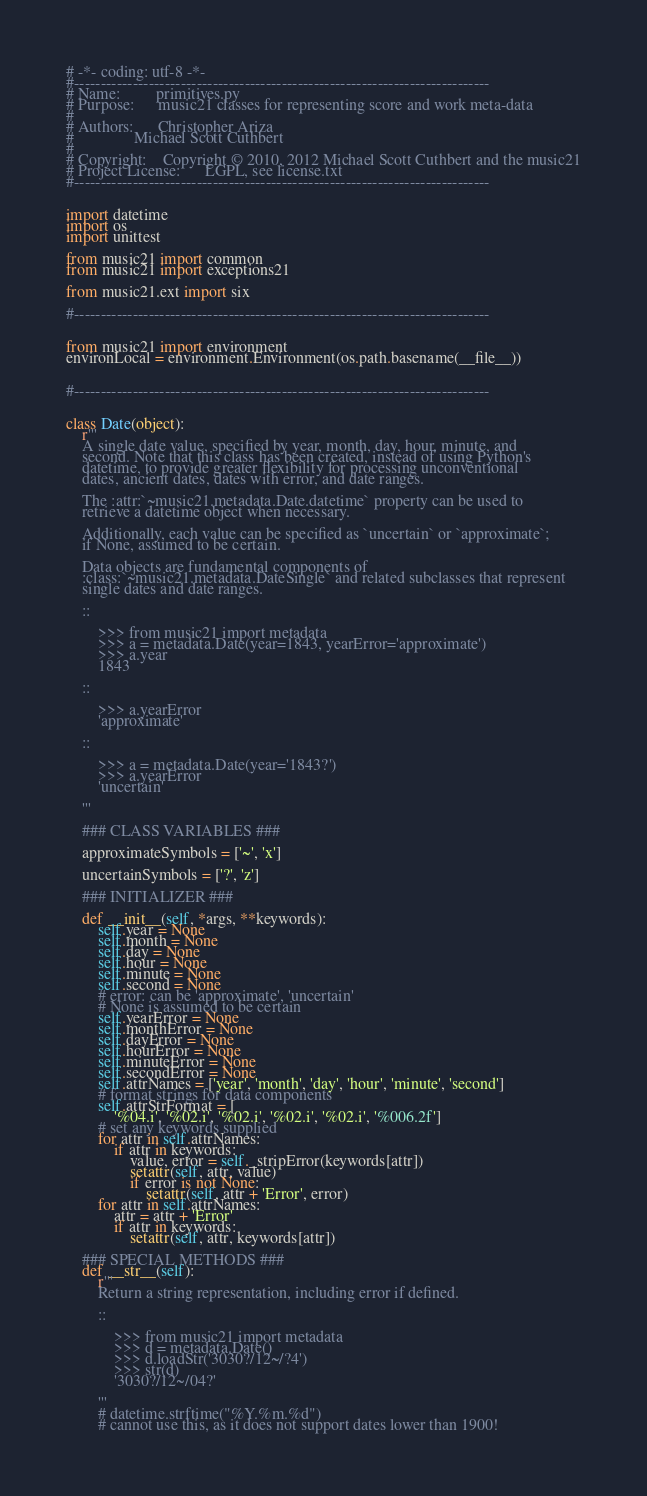Convert code to text. <code><loc_0><loc_0><loc_500><loc_500><_Python_># -*- coding: utf-8 -*-
#------------------------------------------------------------------------------
# Name:         primitives.py
# Purpose:      music21 classes for representing score and work meta-data
#
# Authors:      Christopher Ariza
#               Michael Scott Cuthbert
#
# Copyright:    Copyright © 2010, 2012 Michael Scott Cuthbert and the music21
# Project License:      LGPL, see license.txt
#------------------------------------------------------------------------------


import datetime
import os
import unittest

from music21 import common
from music21 import exceptions21

from music21.ext import six

#------------------------------------------------------------------------------


from music21 import environment
environLocal = environment.Environment(os.path.basename(__file__))


#------------------------------------------------------------------------------


class Date(object):
    r'''
    A single date value, specified by year, month, day, hour, minute, and
    second. Note that this class has been created, instead of using Python's
    datetime, to provide greater flexibility for processing unconventional
    dates, ancient dates, dates with error, and date ranges.

    The :attr:`~music21.metadata.Date.datetime` property can be used to
    retrieve a datetime object when necessary.

    Additionally, each value can be specified as `uncertain` or `approximate`;
    if None, assumed to be certain.

    Data objects are fundamental components of
    :class:`~music21.metadata.DateSingle` and related subclasses that represent
    single dates and date ranges.

    ::

        >>> from music21 import metadata
        >>> a = metadata.Date(year=1843, yearError='approximate')
        >>> a.year
        1843

    ::

        >>> a.yearError
        'approximate'

    ::

        >>> a = metadata.Date(year='1843?')
        >>> a.yearError
        'uncertain'

    '''

    ### CLASS VARIABLES ###

    approximateSymbols = ['~', 'x']

    uncertainSymbols = ['?', 'z']

    ### INITIALIZER ###

    def __init__(self, *args, **keywords):
        self.year = None
        self.month = None
        self.day = None
        self.hour = None
        self.minute = None
        self.second = None
        # error: can be 'approximate', 'uncertain'
        # None is assumed to be certain
        self.yearError = None
        self.monthError = None
        self.dayError = None
        self.hourError = None
        self.minuteError = None
        self.secondError = None
        self.attrNames = ['year', 'month', 'day', 'hour', 'minute', 'second']
        # format strings for data components
        self.attrStrFormat = [
            '%04.i', '%02.i', '%02.i', '%02.i', '%02.i', '%006.2f']
        # set any keywords supplied
        for attr in self.attrNames:
            if attr in keywords:
                value, error = self._stripError(keywords[attr])
                setattr(self, attr, value)
                if error is not None:
                    setattr(self, attr + 'Error', error)
        for attr in self.attrNames:
            attr = attr + 'Error'
            if attr in keywords:
                setattr(self, attr, keywords[attr])

    ### SPECIAL METHODS ###
    def __str__(self):
        r'''
        Return a string representation, including error if defined.

        ::

            >>> from music21 import metadata
            >>> d = metadata.Date()
            >>> d.loadStr('3030?/12~/?4')
            >>> str(d)
            '3030?/12~/04?'

        '''
        # datetime.strftime("%Y.%m.%d")
        # cannot use this, as it does not support dates lower than 1900!</code> 